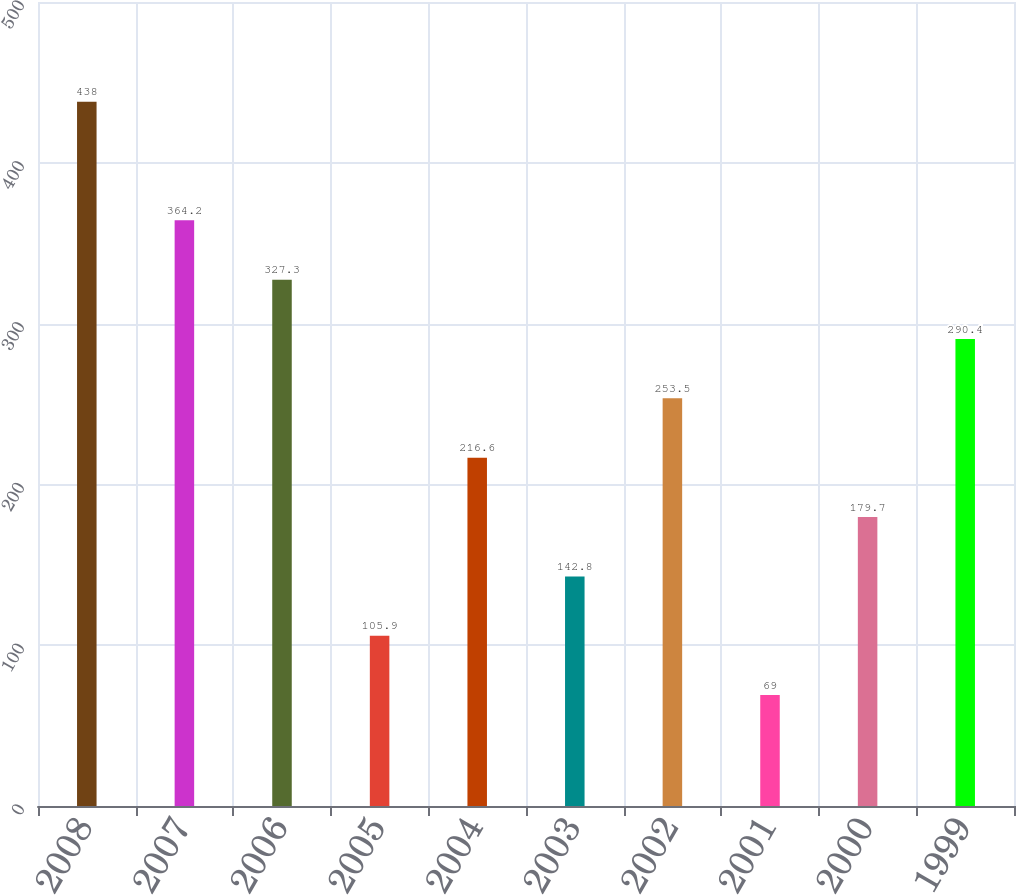Convert chart. <chart><loc_0><loc_0><loc_500><loc_500><bar_chart><fcel>2008<fcel>2007<fcel>2006<fcel>2005<fcel>2004<fcel>2003<fcel>2002<fcel>2001<fcel>2000<fcel>1999<nl><fcel>438<fcel>364.2<fcel>327.3<fcel>105.9<fcel>216.6<fcel>142.8<fcel>253.5<fcel>69<fcel>179.7<fcel>290.4<nl></chart> 